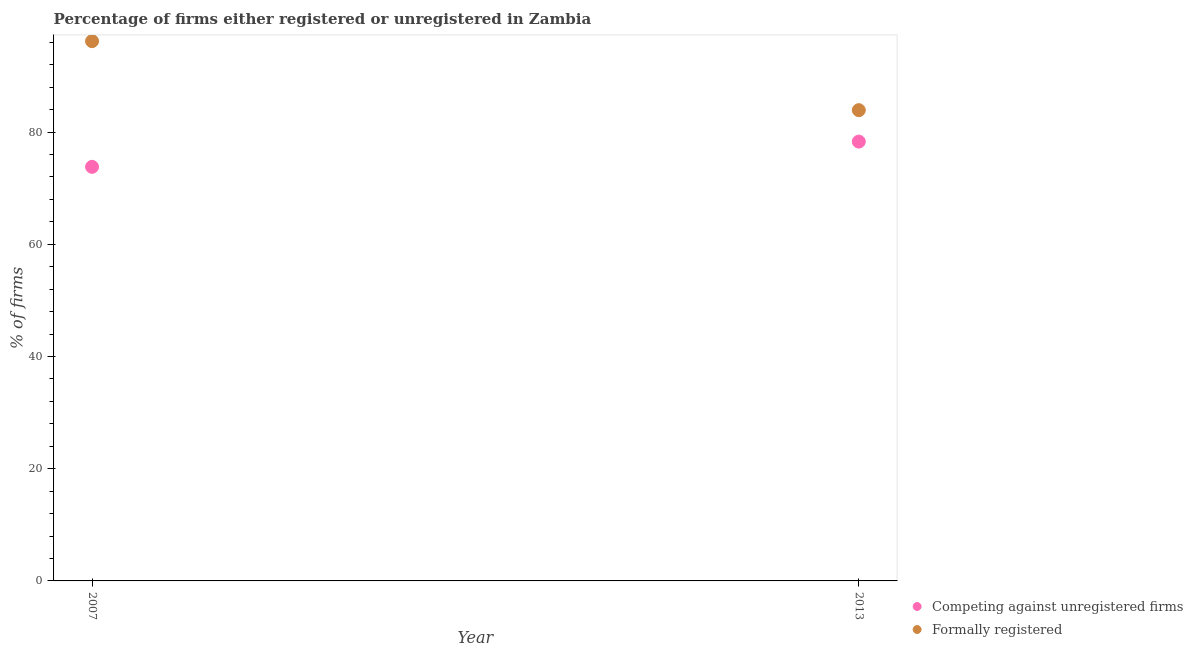What is the percentage of formally registered firms in 2013?
Give a very brief answer. 83.9. Across all years, what is the maximum percentage of registered firms?
Make the answer very short. 78.3. Across all years, what is the minimum percentage of registered firms?
Offer a terse response. 73.8. What is the total percentage of registered firms in the graph?
Keep it short and to the point. 152.1. What is the difference between the percentage of registered firms in 2007 and that in 2013?
Give a very brief answer. -4.5. What is the difference between the percentage of formally registered firms in 2007 and the percentage of registered firms in 2013?
Give a very brief answer. 17.9. What is the average percentage of formally registered firms per year?
Your answer should be very brief. 90.05. In the year 2013, what is the difference between the percentage of registered firms and percentage of formally registered firms?
Your answer should be compact. -5.6. In how many years, is the percentage of formally registered firms greater than 20 %?
Make the answer very short. 2. What is the ratio of the percentage of formally registered firms in 2007 to that in 2013?
Offer a terse response. 1.15. Does the percentage of formally registered firms monotonically increase over the years?
Offer a terse response. No. How many dotlines are there?
Your response must be concise. 2. What is the difference between two consecutive major ticks on the Y-axis?
Keep it short and to the point. 20. Does the graph contain any zero values?
Offer a terse response. No. Does the graph contain grids?
Offer a terse response. No. What is the title of the graph?
Your answer should be very brief. Percentage of firms either registered or unregistered in Zambia. What is the label or title of the X-axis?
Your answer should be compact. Year. What is the label or title of the Y-axis?
Your response must be concise. % of firms. What is the % of firms of Competing against unregistered firms in 2007?
Ensure brevity in your answer.  73.8. What is the % of firms of Formally registered in 2007?
Ensure brevity in your answer.  96.2. What is the % of firms of Competing against unregistered firms in 2013?
Your response must be concise. 78.3. What is the % of firms of Formally registered in 2013?
Offer a terse response. 83.9. Across all years, what is the maximum % of firms of Competing against unregistered firms?
Offer a very short reply. 78.3. Across all years, what is the maximum % of firms in Formally registered?
Provide a short and direct response. 96.2. Across all years, what is the minimum % of firms of Competing against unregistered firms?
Make the answer very short. 73.8. Across all years, what is the minimum % of firms of Formally registered?
Provide a short and direct response. 83.9. What is the total % of firms in Competing against unregistered firms in the graph?
Offer a very short reply. 152.1. What is the total % of firms of Formally registered in the graph?
Your answer should be compact. 180.1. What is the difference between the % of firms of Competing against unregistered firms in 2007 and that in 2013?
Ensure brevity in your answer.  -4.5. What is the difference between the % of firms in Competing against unregistered firms in 2007 and the % of firms in Formally registered in 2013?
Make the answer very short. -10.1. What is the average % of firms in Competing against unregistered firms per year?
Your response must be concise. 76.05. What is the average % of firms in Formally registered per year?
Your response must be concise. 90.05. In the year 2007, what is the difference between the % of firms in Competing against unregistered firms and % of firms in Formally registered?
Ensure brevity in your answer.  -22.4. What is the ratio of the % of firms in Competing against unregistered firms in 2007 to that in 2013?
Make the answer very short. 0.94. What is the ratio of the % of firms of Formally registered in 2007 to that in 2013?
Offer a very short reply. 1.15. What is the difference between the highest and the second highest % of firms of Competing against unregistered firms?
Provide a succinct answer. 4.5. What is the difference between the highest and the second highest % of firms in Formally registered?
Your response must be concise. 12.3. 